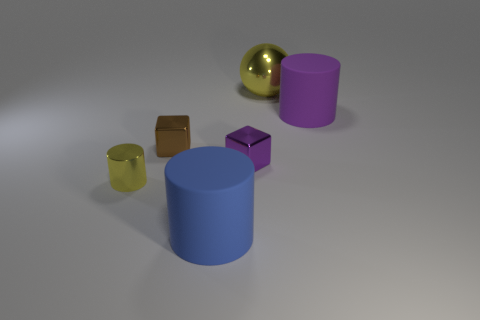Are there an equal number of big yellow balls that are behind the sphere and small brown spheres? Actually, upon careful observation, it appears there is only one big yellow ball and no small brown spheres at all. The image shows a variety of geometric shapes including a big yellow sphere, but there are no small brown spheres to compare quantities with. 